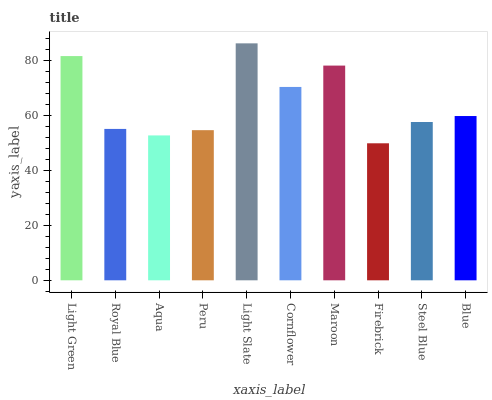Is Firebrick the minimum?
Answer yes or no. Yes. Is Light Slate the maximum?
Answer yes or no. Yes. Is Royal Blue the minimum?
Answer yes or no. No. Is Royal Blue the maximum?
Answer yes or no. No. Is Light Green greater than Royal Blue?
Answer yes or no. Yes. Is Royal Blue less than Light Green?
Answer yes or no. Yes. Is Royal Blue greater than Light Green?
Answer yes or no. No. Is Light Green less than Royal Blue?
Answer yes or no. No. Is Blue the high median?
Answer yes or no. Yes. Is Steel Blue the low median?
Answer yes or no. Yes. Is Royal Blue the high median?
Answer yes or no. No. Is Light Green the low median?
Answer yes or no. No. 